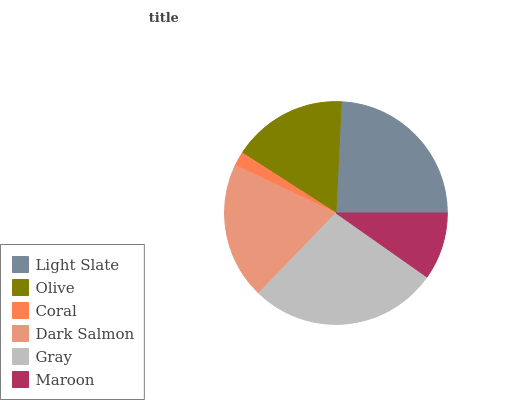Is Coral the minimum?
Answer yes or no. Yes. Is Gray the maximum?
Answer yes or no. Yes. Is Olive the minimum?
Answer yes or no. No. Is Olive the maximum?
Answer yes or no. No. Is Light Slate greater than Olive?
Answer yes or no. Yes. Is Olive less than Light Slate?
Answer yes or no. Yes. Is Olive greater than Light Slate?
Answer yes or no. No. Is Light Slate less than Olive?
Answer yes or no. No. Is Dark Salmon the high median?
Answer yes or no. Yes. Is Olive the low median?
Answer yes or no. Yes. Is Maroon the high median?
Answer yes or no. No. Is Gray the low median?
Answer yes or no. No. 